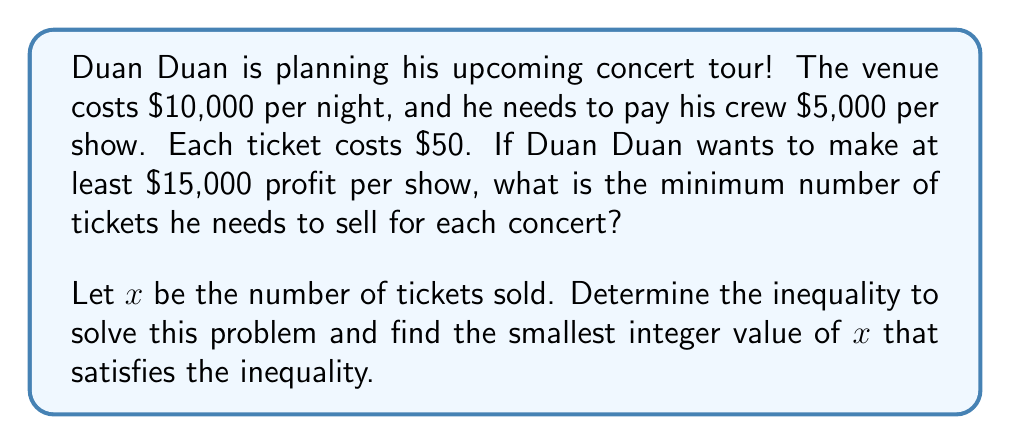Show me your answer to this math problem. Let's approach this step-by-step:

1) First, let's define our variables:
   $x$ = number of tickets sold
   $50x$ = total revenue from ticket sales

2) Now, let's set up our inequality:
   Revenue - Costs ≥ Desired Profit
   $50x - (10000 + 5000) \geq 15000$

3) Simplify:
   $50x - 15000 \geq 15000$

4) Add 15000 to both sides:
   $50x \geq 30000$

5) Divide both sides by 50:
   $x \geq 600$

6) Since we can't sell a fraction of a ticket, we need to round up to the nearest whole number. 

Therefore, the minimum number of tickets Duan Duan needs to sell is 600.

7) Let's verify:
   Revenue: $600 * $50 = $30,000
   Costs: $10,000 + $5,000 = $15,000
   Profit: $30,000 - $15,000 = $15,000

   This confirms our answer meets the minimum profit requirement.
Answer: 600 tickets 